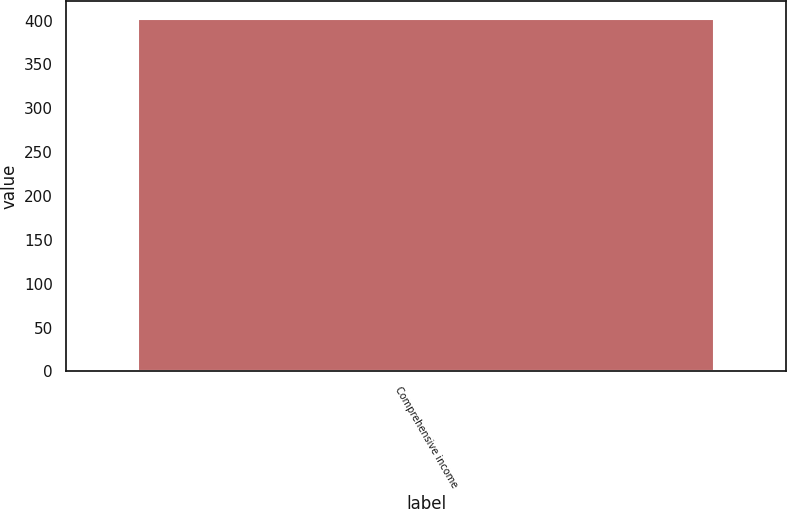Convert chart to OTSL. <chart><loc_0><loc_0><loc_500><loc_500><bar_chart><fcel>Comprehensive income<nl><fcel>402.1<nl></chart> 